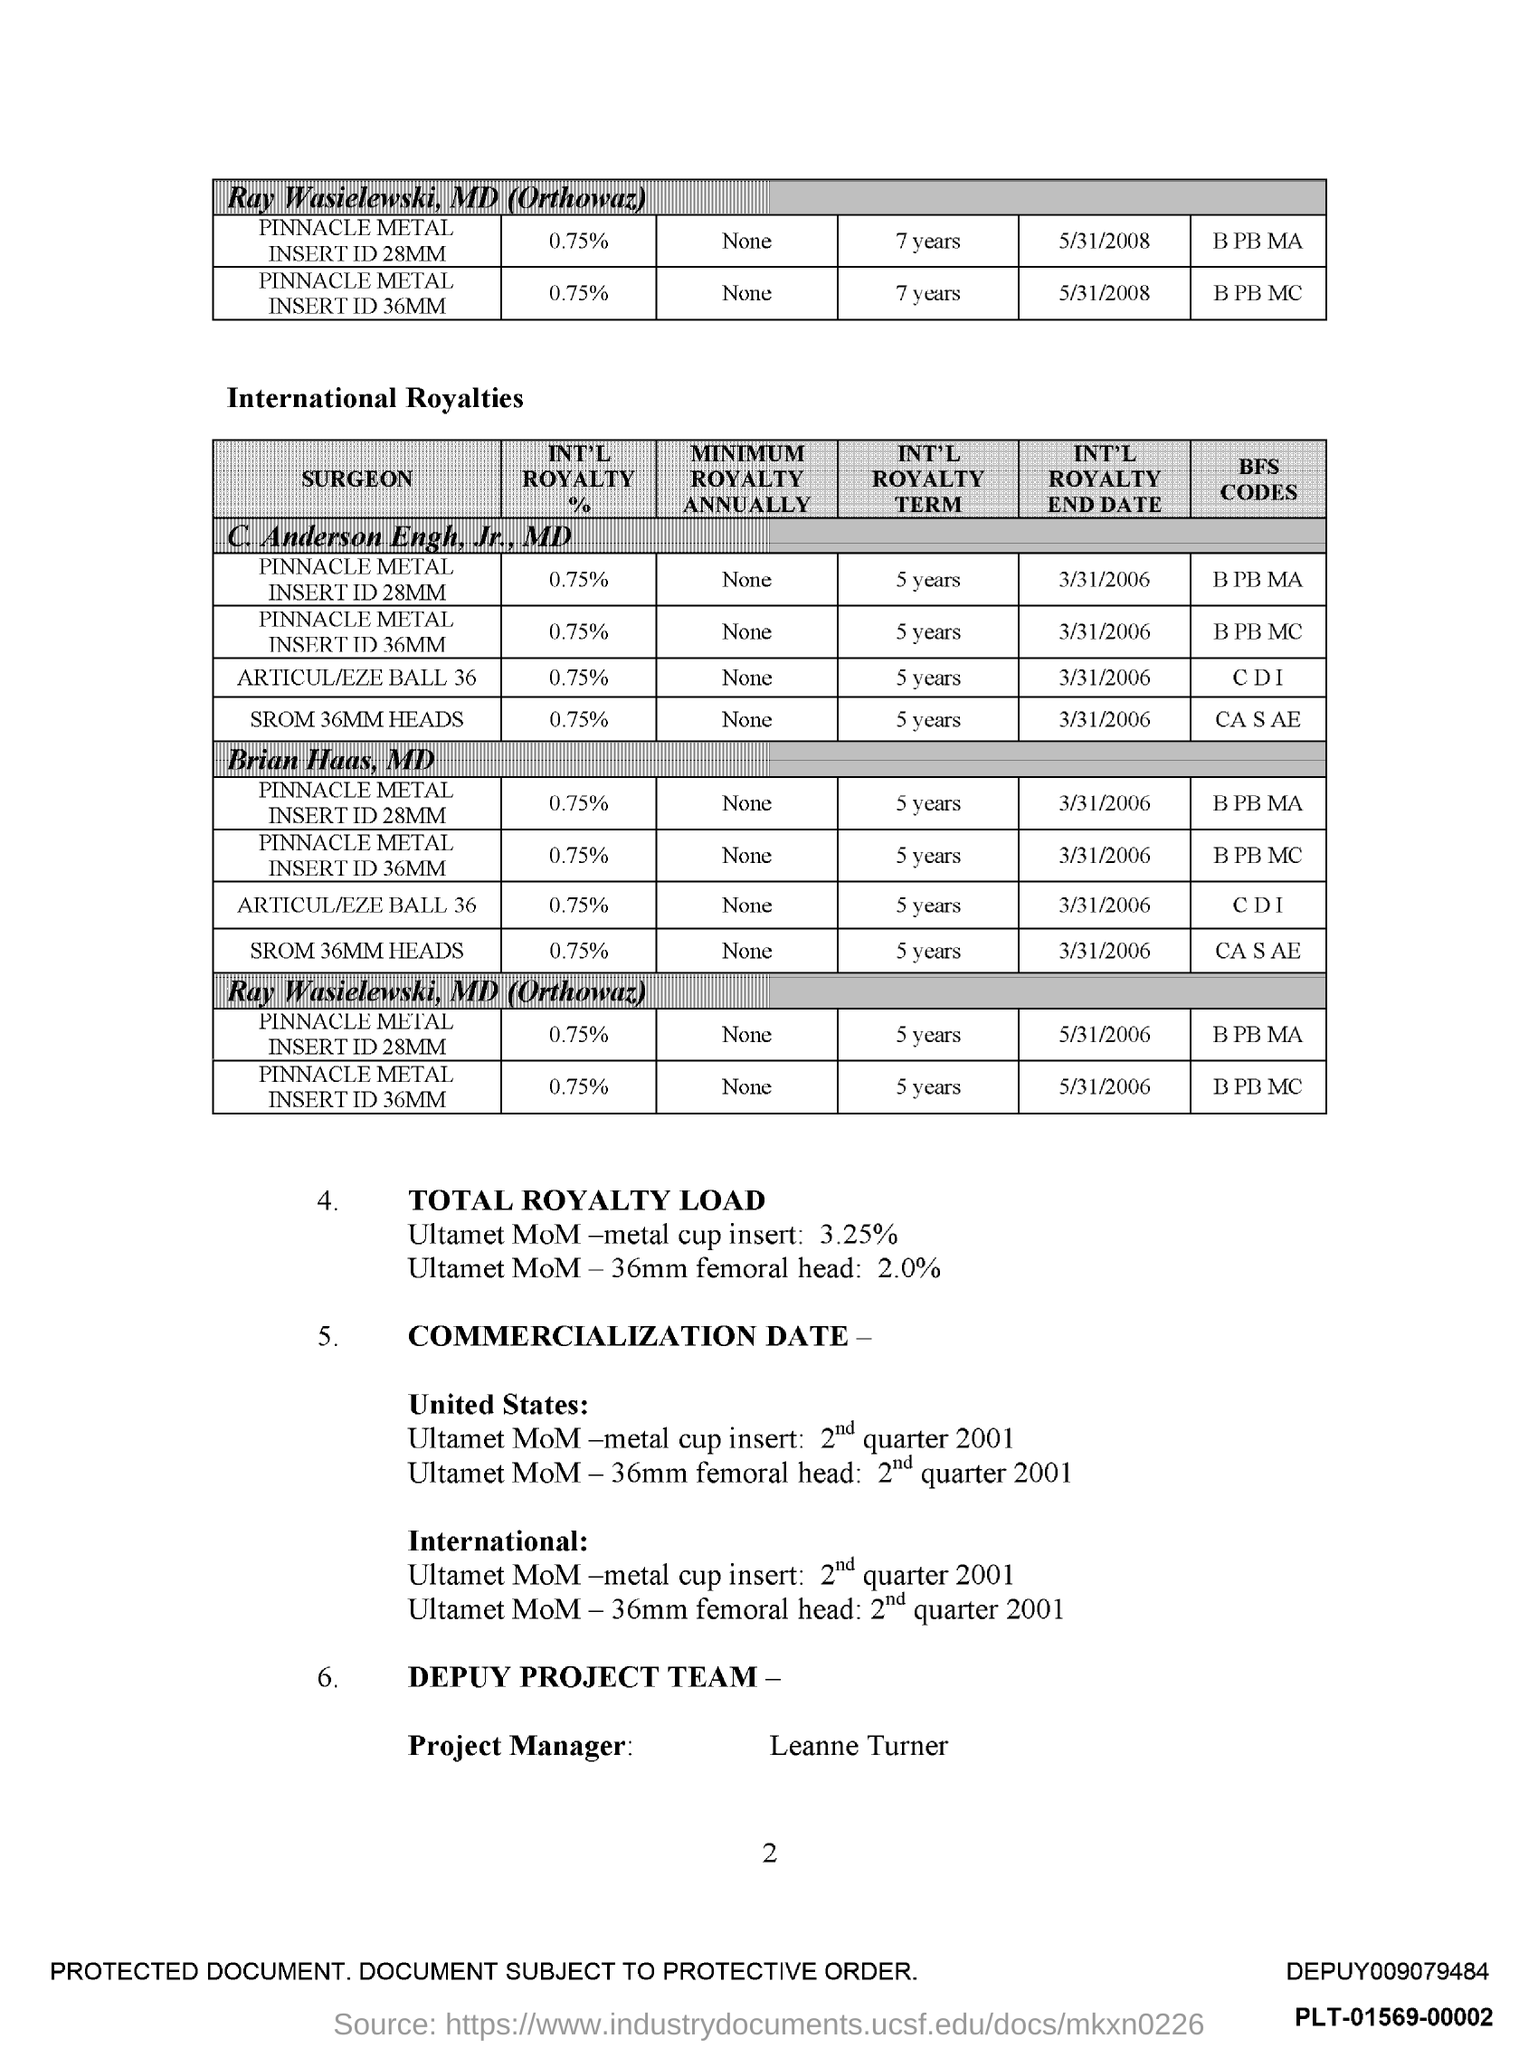Specify some key components in this picture. The name of the project manager is Leanne Turner. 